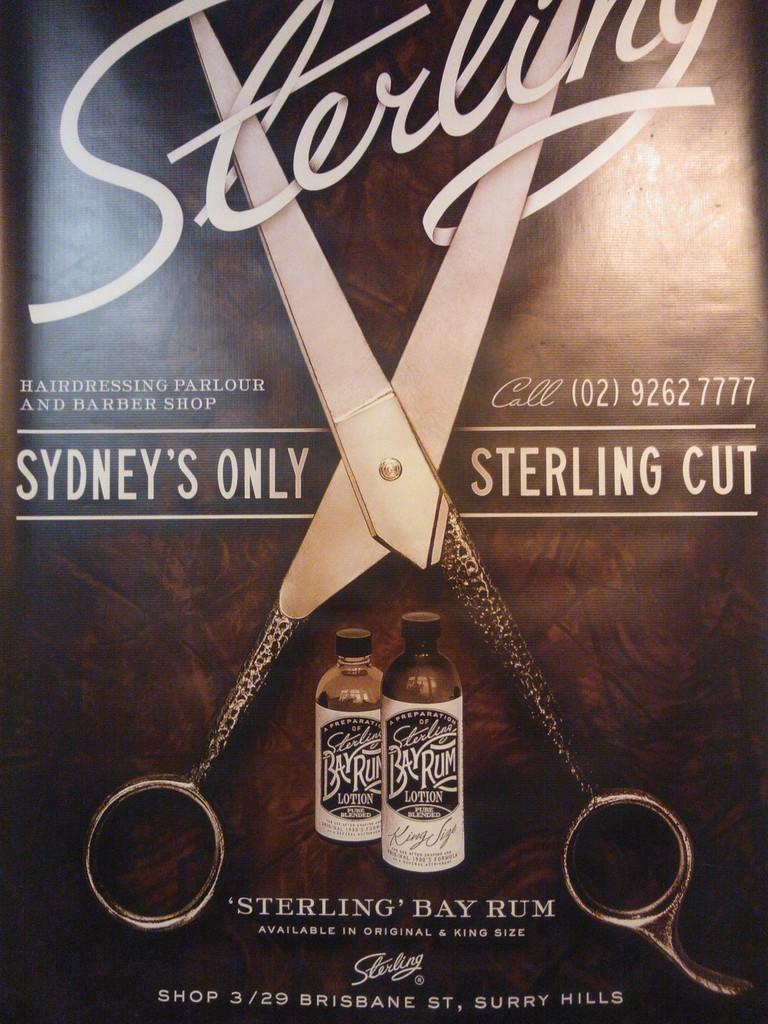Provide a one-sentence caption for the provided image. An advertisement for Sterling Bay Rum depicting an open scissor in the middle of the advertisement. 